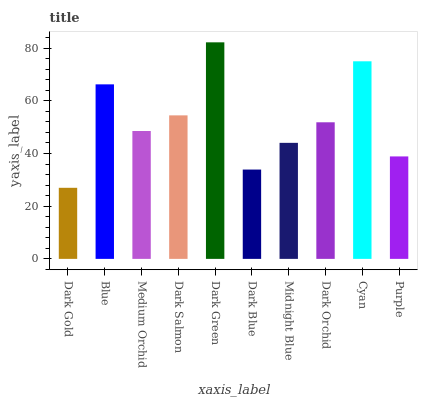Is Blue the minimum?
Answer yes or no. No. Is Blue the maximum?
Answer yes or no. No. Is Blue greater than Dark Gold?
Answer yes or no. Yes. Is Dark Gold less than Blue?
Answer yes or no. Yes. Is Dark Gold greater than Blue?
Answer yes or no. No. Is Blue less than Dark Gold?
Answer yes or no. No. Is Dark Orchid the high median?
Answer yes or no. Yes. Is Medium Orchid the low median?
Answer yes or no. Yes. Is Dark Gold the high median?
Answer yes or no. No. Is Dark Salmon the low median?
Answer yes or no. No. 